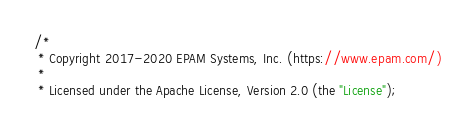Convert code to text. <code><loc_0><loc_0><loc_500><loc_500><_JavaScript_>/*
 * Copyright 2017-2020 EPAM Systems, Inc. (https://www.epam.com/)
 *
 * Licensed under the Apache License, Version 2.0 (the "License");</code> 